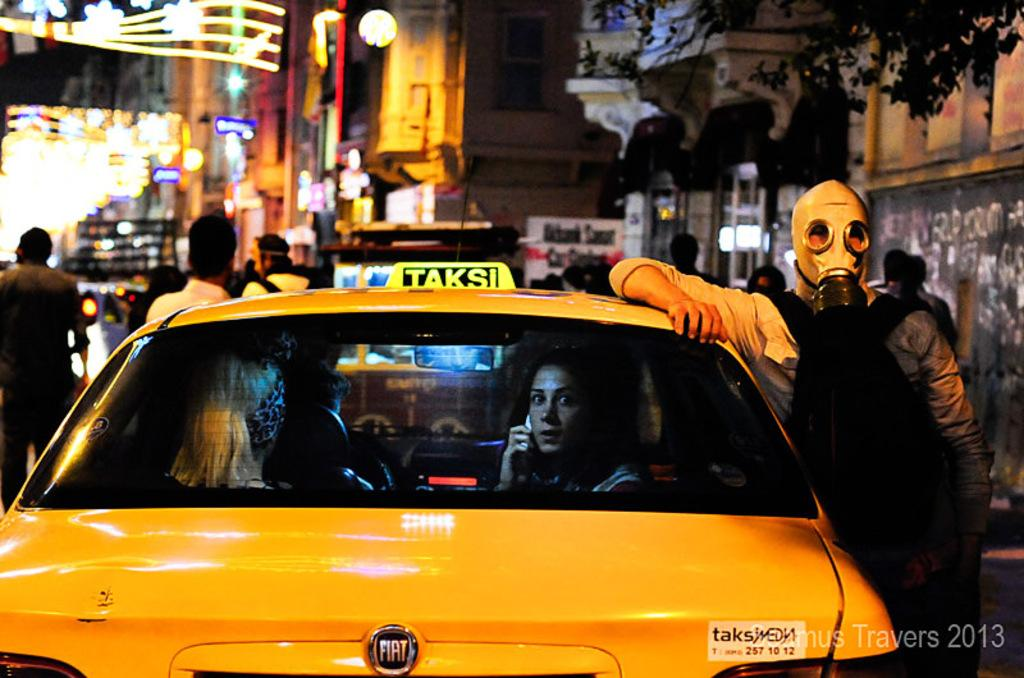<image>
Share a concise interpretation of the image provided. The man with the gas mask is leaning on yellow car with the medallion reading TAKSI. 